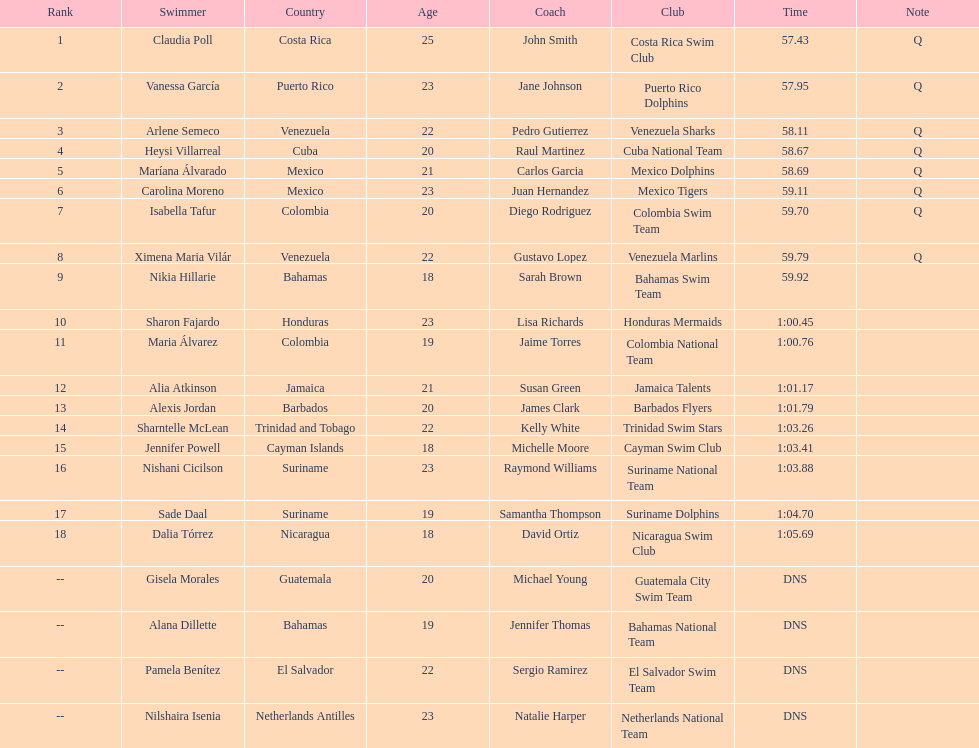Help me parse the entirety of this table. {'header': ['Rank', 'Swimmer', 'Country', 'Age', 'Coach', 'Club', 'Time', 'Note'], 'rows': [['1', 'Claudia Poll', 'Costa Rica', '25', 'John Smith', 'Costa Rica Swim Club', '57.43', 'Q'], ['2', 'Vanessa García', 'Puerto Rico', '23', 'Jane Johnson', 'Puerto Rico Dolphins', '57.95', 'Q'], ['3', 'Arlene Semeco', 'Venezuela', '22', 'Pedro Gutierrez', 'Venezuela Sharks', '58.11', 'Q'], ['4', 'Heysi Villarreal', 'Cuba', '20', 'Raul Martinez', 'Cuba National Team', '58.67', 'Q'], ['5', 'Maríana Álvarado', 'Mexico', '21', 'Carlos Garcia', 'Mexico Dolphins', '58.69', 'Q'], ['6', 'Carolina Moreno', 'Mexico', '23', 'Juan Hernandez', 'Mexico Tigers', '59.11', 'Q'], ['7', 'Isabella Tafur', 'Colombia', '20', 'Diego Rodriguez', 'Colombia Swim Team', '59.70', 'Q'], ['8', 'Ximena Maria Vilár', 'Venezuela', '22', 'Gustavo Lopez', 'Venezuela Marlins', '59.79', 'Q'], ['9', 'Nikia Hillarie', 'Bahamas', '18', 'Sarah Brown', 'Bahamas Swim Team', '59.92', ''], ['10', 'Sharon Fajardo', 'Honduras', '23', 'Lisa Richards', 'Honduras Mermaids', '1:00.45', ''], ['11', 'Maria Álvarez', 'Colombia', '19', 'Jaime Torres', 'Colombia National Team', '1:00.76', ''], ['12', 'Alia Atkinson', 'Jamaica', '21', 'Susan Green', 'Jamaica Talents', '1:01.17', ''], ['13', 'Alexis Jordan', 'Barbados', '20', 'James Clark', 'Barbados Flyers', '1:01.79', ''], ['14', 'Sharntelle McLean', 'Trinidad and Tobago', '22', 'Kelly White', 'Trinidad Swim Stars', '1:03.26', ''], ['15', 'Jennifer Powell', 'Cayman Islands', '18', 'Michelle Moore', 'Cayman Swim Club', '1:03.41', ''], ['16', 'Nishani Cicilson', 'Suriname', '23', 'Raymond Williams', 'Suriname National Team', '1:03.88', ''], ['17', 'Sade Daal', 'Suriname', '19', 'Samantha Thompson', 'Suriname Dolphins', '1:04.70', ''], ['18', 'Dalia Tórrez', 'Nicaragua', '18', 'David Ortiz', 'Nicaragua Swim Club', '1:05.69', ''], ['--', 'Gisela Morales', 'Guatemala', '20', 'Michael Young', 'Guatemala City Swim Team', 'DNS', ''], ['--', 'Alana Dillette', 'Bahamas', '19', 'Jennifer Thomas', 'Bahamas National Team', 'DNS', ''], ['--', 'Pamela Benítez', 'El Salvador', '22', 'Sergio Ramirez', 'El Salvador Swim Team', 'DNS', ''], ['--', 'Nilshaira Isenia', 'Netherlands Antilles', '23', 'Natalie Harper', 'Netherlands National Team', 'DNS', '']]} Who were the swimmers at the 2006 central american and caribbean games - women's 100 metre freestyle? Claudia Poll, Vanessa García, Arlene Semeco, Heysi Villarreal, Maríana Álvarado, Carolina Moreno, Isabella Tafur, Ximena Maria Vilár, Nikia Hillarie, Sharon Fajardo, Maria Álvarez, Alia Atkinson, Alexis Jordan, Sharntelle McLean, Jennifer Powell, Nishani Cicilson, Sade Daal, Dalia Tórrez, Gisela Morales, Alana Dillette, Pamela Benítez, Nilshaira Isenia. Of these which were from cuba? Heysi Villarreal. 